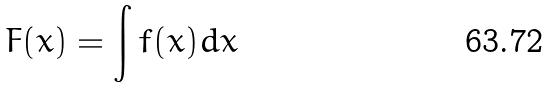Convert formula to latex. <formula><loc_0><loc_0><loc_500><loc_500>F ( x ) = \int f ( x ) d x</formula> 